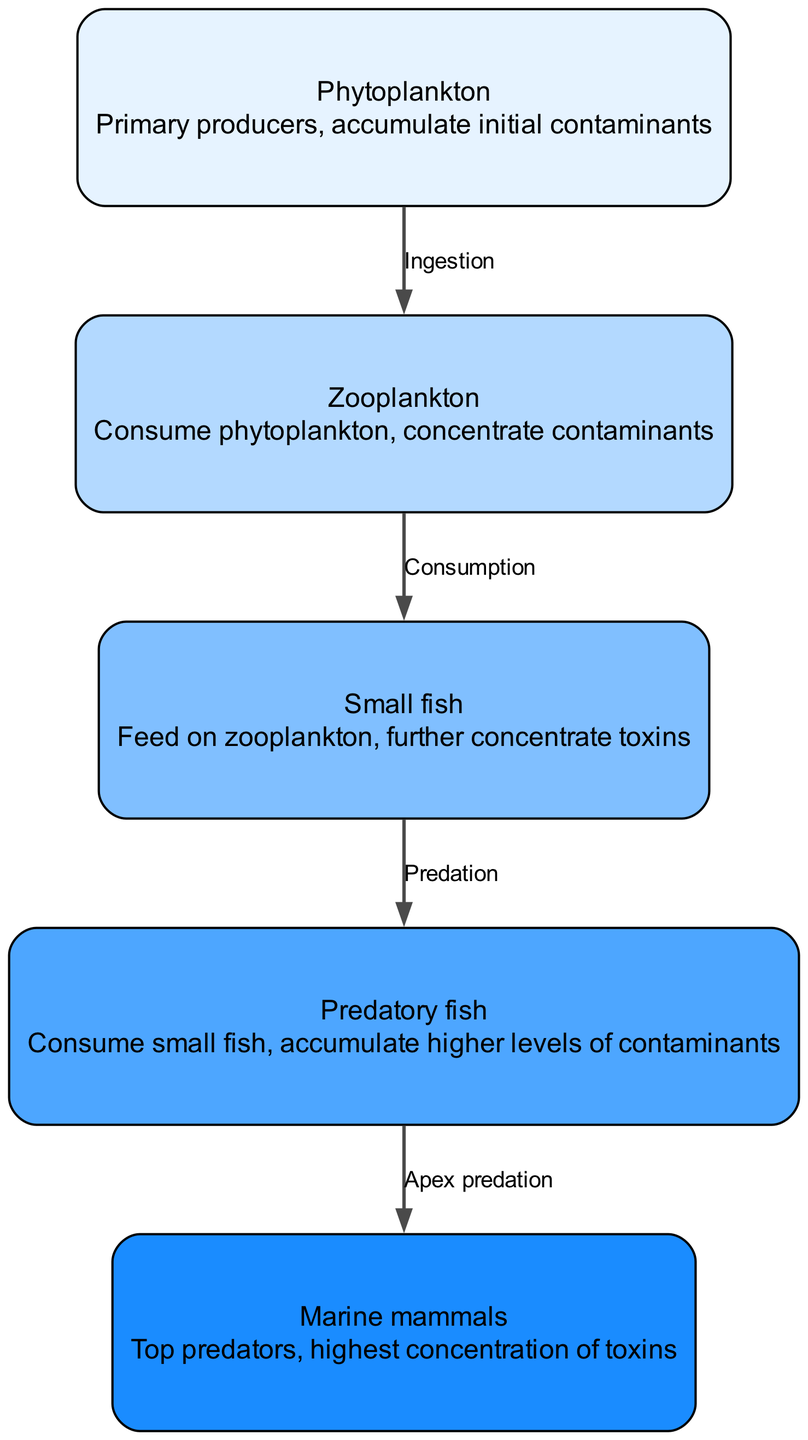What is the first node in the food chain? The first node in the food chain is identified as "Phytoplankton." It is the primary producer and accumulates initial contaminants in the system.
Answer: Phytoplankton How many nodes are there in the diagram? By counting the specific node entries in the provided data, there are a total of five nodes representing different levels in the marine food chain.
Answer: 5 What interaction occurs between phytoplankton and zooplankton? The interaction between phytoplankton and zooplankton is described as "Ingestion," indicating that zooplankton consume phytoplankton and therefore accumulate contaminants.
Answer: Ingestion Which organism is at the top of the food chain? The top organism in the food chain is "Marine mammals," as they are positioned to receive the highest concentration of toxins through the food chain.
Answer: Marine mammals What type of relationship exists between predatory fish and small fish? The relationship between predatory fish and small fish is characterized by "Predation," indicating that predatory fish consume small fish as part of their feeding behavior and thereby accumulate contaminants.
Answer: Predation What is the sequence of nodes from phytoplankton to marine mammals? The sequence starts with "Phytoplankton," which is consumed by "Zooplankton," then leads to "Small fish," followed by "Predatory fish," and finally the apex predator, "Marine mammals."
Answer: Phytoplankton, Zooplankton, Small fish, Predatory fish, Marine mammals How do contaminants move through the food chain? Contaminants move through the food chain by being accumulated by each successive level of organisms as they consume each other; starting with phytoplankton and increasingly concentrating up to marine mammals.
Answer: By consumption What is the last interaction shown in the diagram? The last interaction depicted in the diagram is labeled "Apex predation," which connects "Predatory fish" to "Marine mammals," indicating that marine mammals are the final consumers in this food chain.
Answer: Apex predation 